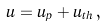Convert formula to latex. <formula><loc_0><loc_0><loc_500><loc_500>u = u _ { p } + u _ { t h } \, ,</formula> 